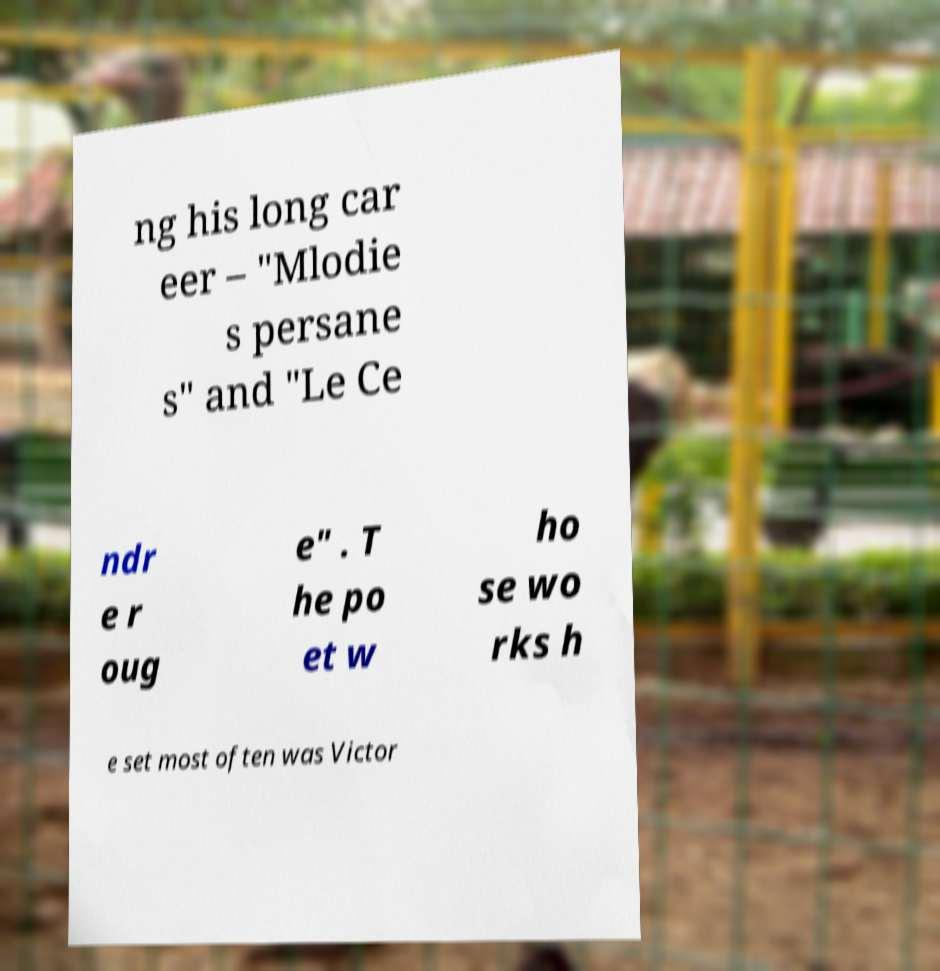Can you read and provide the text displayed in the image?This photo seems to have some interesting text. Can you extract and type it out for me? ng his long car eer – "Mlodie s persane s" and "Le Ce ndr e r oug e" . T he po et w ho se wo rks h e set most often was Victor 